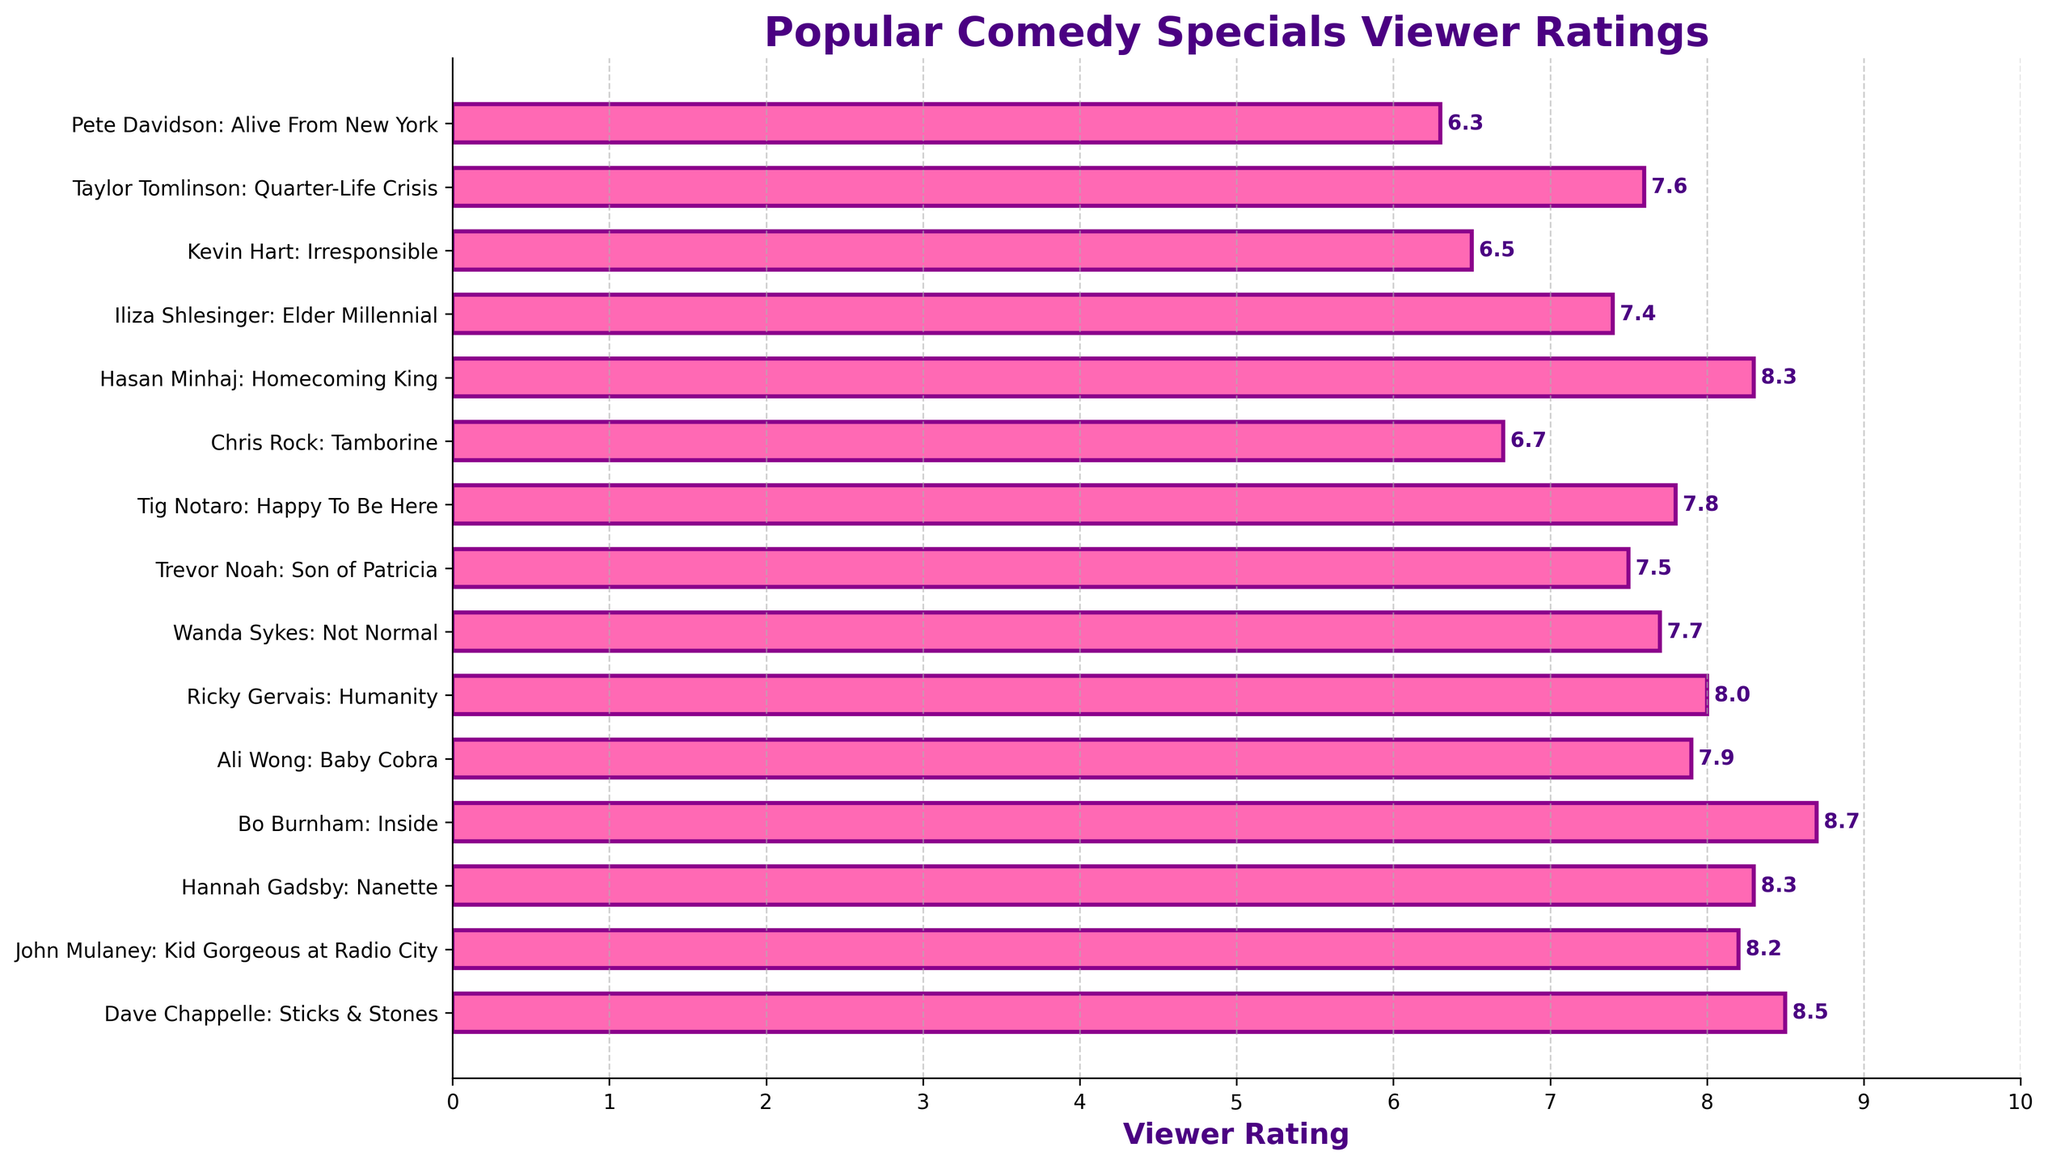Which comedy special has the highest viewer rating? Bo Burnham: Inside has the highest bar, which indicates the highest rating among the specials listed.
Answer: Bo Burnham: Inside Which comedy special has the lowest viewer rating? Pete Davidson: Alive From New York has the shortest bar, which indicates the lowest rating among the specials listed.
Answer: Pete Davidson: Alive From New York How many comedy specials have a viewer rating of 8.0 or higher? Counting the bars with ratings of 8.0 or higher gives Dave Chappelle: Sticks & Stones, John Mulaney: Kid Gorgeous at Radio City, Hannah Gadsby: Nanette, Bo Burnham: Inside, Ricky Gervais: Humanity, and Hasan Minhaj: Homecoming King, which totals to 6 specials.
Answer: 6 What's the total sum of the viewer ratings for the comedy specials with ratings greater than 8.0? The specials with ratings greater than 8.0 are Dave Chappelle: Sticks & Stones (8.5), John Mulaney: Kid Gorgeous at Radio City (8.2), Hannah Gadsby: Nanette (8.3), Bo Burnham: Inside (8.7), and Hasan Minhaj: Homecoming King (8.3). Summing these: 8.5 + 8.2 + 8.3 + 8.7 + 8.3 = 42.0
Answer: 42.0 Which comedy specials have a lower viewer rating than Ali Wong: Baby Cobra? Ali Wong: Baby Cobra has a rating of 7.9. The specials with lower ratings are Ricky Gervais: Humanity (8.0), Wanda Sykes: Not Normal (7.7), Trevor Noah: Son of Patricia (7.5), Tig Notaro: Happy To Be Here (7.8), Chris Rock: Tamborine (6.7), Iliza Shlesinger: Elder Millennial (7.4), Kevin Hart: Irresponsible (6.5), Taylor Tomlinson: Quarter-Life Crisis (7.6), and Pete Davidson: Alive From New York (6.3).
Answer: Wanda Sykes: Not Normal, Trevor Noah: Son of Patricia, Tig Notaro: Happy To Be Here, Chris Rock: Tamborine, Iliza Shlesinger: Elder Millennial, Kevin Hart: Irresponsible, Taylor Tomlinson: Quarter-Life Crisis, Pete Davidson: Alive From New York How many comedy specials are rated between 7.0 and 8.0 inclusive? Counting the bars with ratings within the range 7.0 to 8.0 inclusive gives us Ali Wong: Baby Cobra (7.9), Ricky Gervais: Humanity (8.0), Wanda Sykes: Not Normal (7.7), Tig Notaro: Happy To Be Here (7.8), Trevor Noah: Son of Patricia (7.5), and Taylor Tomlinson: Quarter-Life Crisis (7.6), which totals to 6 specials.
Answer: 6 What's the difference in viewer rating between Bo Burnham: Inside and Kevin Hart: Irresponsible? The rating for Bo Burnham: Inside is 8.7 and for Kevin Hart: Irresponsible is 6.5. Their difference is calculated as 8.7 - 6.5 = 2.2.
Answer: 2.2 Which comedy special is rated closest to the average rating of the specials listed? To find the average rating: Sum all ratings: 8.5 + 8.2 + 8.3 + 8.7 + 7.9 + 8.0 + 7.7 + 7.5 + 7.8 + 6.7 + 8.3 + 7.4 + 6.5 + 7.6 + 6.3 = 115.4; Divide by the number of specials: 115.4 / 15 ≈ 7.69. The closest specials are Ali Wong: Baby Cobra at 7.9 and Tig Notaro: Happy To Be Here at 7.8.
Answer: Tig Notaro: Happy To Be Here and Ali Wong: Baby Cobra How many comedy specials have a viewer rating below 7.0? Counting the bars with ratings less than 7.0 gives Chris Rock: Tamborine (6.7), Kevin Hart: Irresponsible (6.5), and Pete Davidson: Alive From New York (6.3), which totals to 3 specials.
Answer: 3 